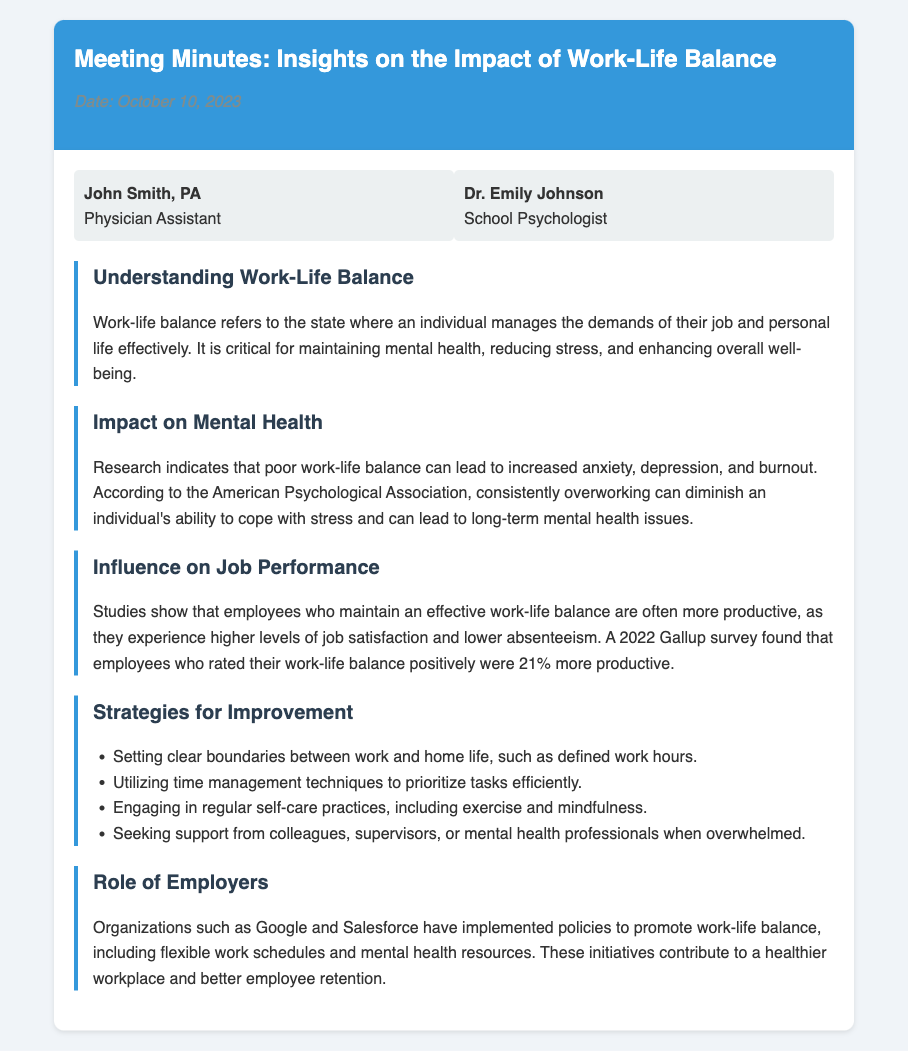What is the date of the meeting? The date of the meeting is mentioned in the header of the document.
Answer: October 10, 2023 Who is the school psychologist attending the meeting? The name is listed in the attendees section.
Answer: Dr. Emily Johnson What does work-life balance refer to? The document describes work-life balance in the first key point section.
Answer: The state where an individual manages the demands of their job and personal life effectively According to the American Psychological Association, what can poor work-life balance lead to? This information is found in the impact on mental health section.
Answer: Increased anxiety, depression, and burnout What is the percentage by which employees with a positive work-life balance are more productive according to the Gallup survey? This statistic is included in the influence on job performance section.
Answer: 21% What type of organizations implement policies to promote work-life balance? This is mentioned in the role of employers section in reference to specific companies.
Answer: Google and Salesforce What is one of the strategies for improvement mentioned in the document? Strategies for improvement are listed in the respective section.
Answer: Setting clear boundaries between work and home life What is the purpose of the meeting minutes document? The intent of the document is inferred from its title.
Answer: To provide insights on the impact of work-life balance 